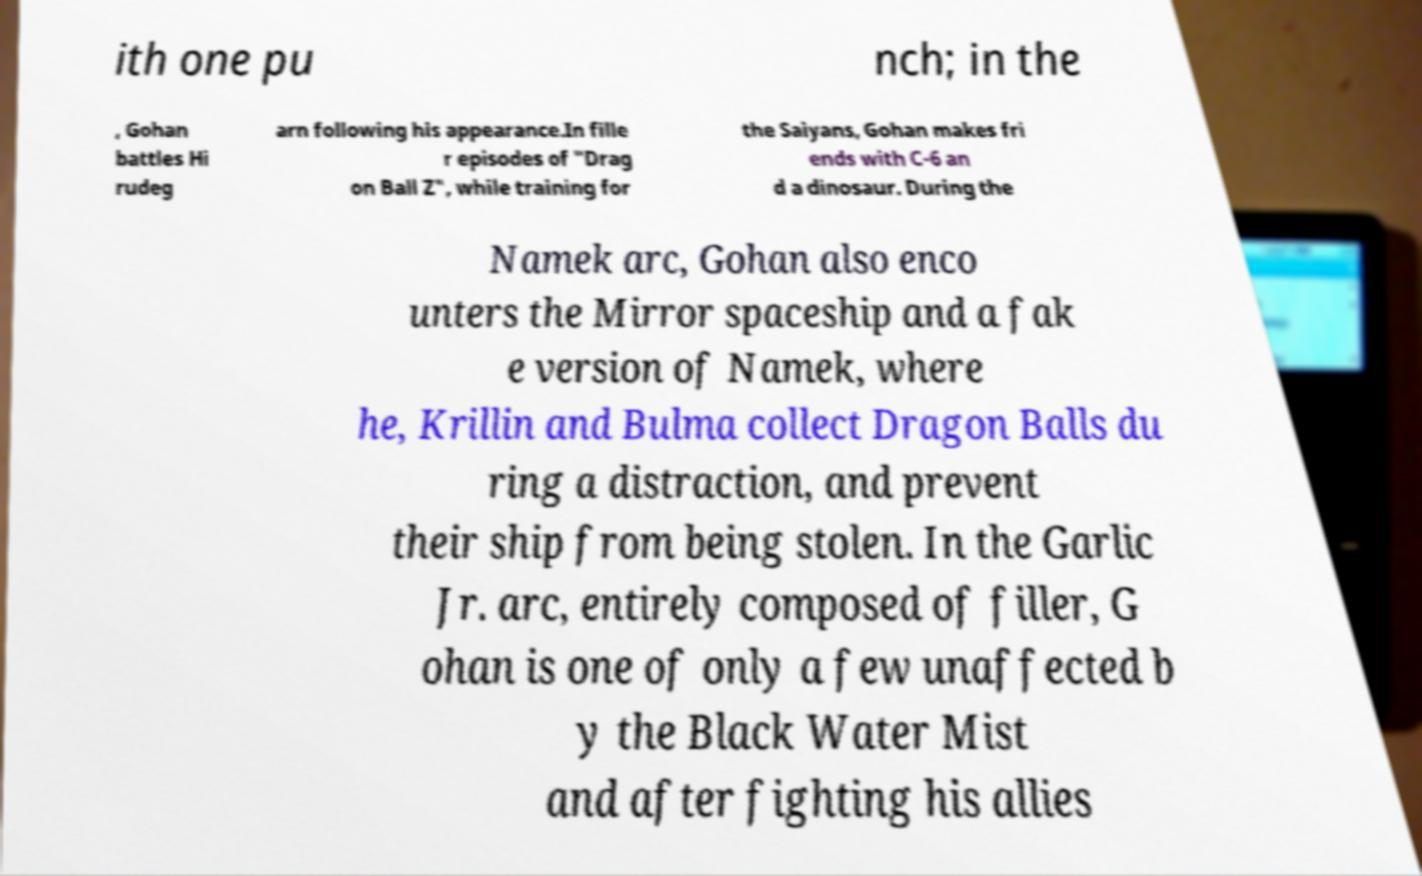There's text embedded in this image that I need extracted. Can you transcribe it verbatim? ith one pu nch; in the , Gohan battles Hi rudeg arn following his appearance.In fille r episodes of "Drag on Ball Z", while training for the Saiyans, Gohan makes fri ends with C-6 an d a dinosaur. During the Namek arc, Gohan also enco unters the Mirror spaceship and a fak e version of Namek, where he, Krillin and Bulma collect Dragon Balls du ring a distraction, and prevent their ship from being stolen. In the Garlic Jr. arc, entirely composed of filler, G ohan is one of only a few unaffected b y the Black Water Mist and after fighting his allies 